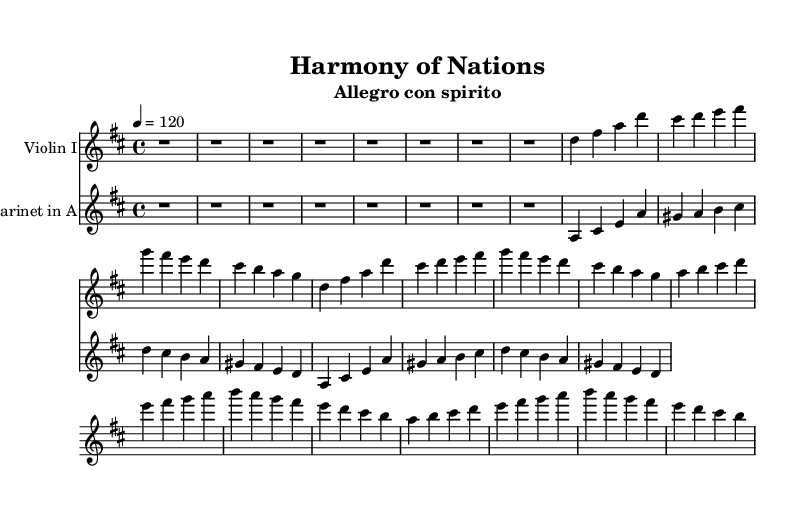What is the key signature of this music? The key signature shows two sharps, which indicates that the piece is in D major.
Answer: D major What is the time signature used in this symphony? The time signature is 4/4, which means there are four beats in each measure, and the quarter note gets one beat.
Answer: 4/4 What is the tempo marking for this symphony? The tempo marking indicates an "Allegro con spirito," suggesting a lively and spirited performance.
Answer: Allegro con spirito What are the instrumentations used in this score? The score includes a Violin I and a Clarinet in A, which are standard instruments in a symphonic setting.
Answer: Violin I, Clarinet in A How many distinct themes are presented in the violin part? The violin part contains two distinct themes: Theme A (a Western motif) and Theme B (an Eastern motif).
Answer: Two themes What is the nature of the counter melody in the clarinet part? The counter melody complements the main themes presented by the violin, providing harmonic support and enrichment to the overall texture.
Answer: Complementary 